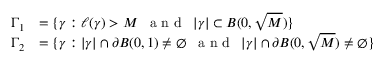Convert formula to latex. <formula><loc_0><loc_0><loc_500><loc_500>\begin{array} { r l } { \Gamma _ { 1 } } & { = \{ \gamma \colon \ell ( \gamma ) > M \, a n d \, | \gamma | \subset B ( 0 , \sqrt { M } ) \} } \\ { \Gamma _ { 2 } } & { = \{ \gamma \colon | \gamma | \cap \partial B ( 0 , 1 ) \neq \emptyset \, a n d \, | \gamma | \cap \partial B ( 0 , \sqrt { M } ) \neq \emptyset \} } \end{array}</formula> 